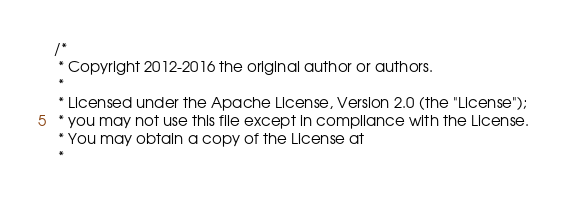Convert code to text. <code><loc_0><loc_0><loc_500><loc_500><_Java_>/*
 * Copyright 2012-2016 the original author or authors.
 *
 * Licensed under the Apache License, Version 2.0 (the "License");
 * you may not use this file except in compliance with the License.
 * You may obtain a copy of the License at
 *</code> 